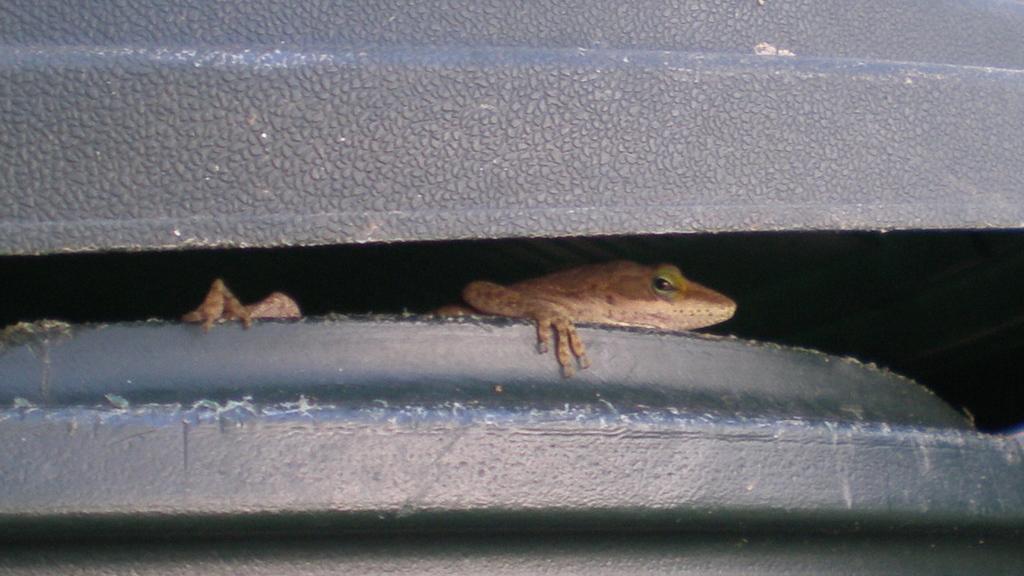In one or two sentences, can you explain what this image depicts? In this image we can see one reptile on the black object, two objects on the top and bottom of the image. 